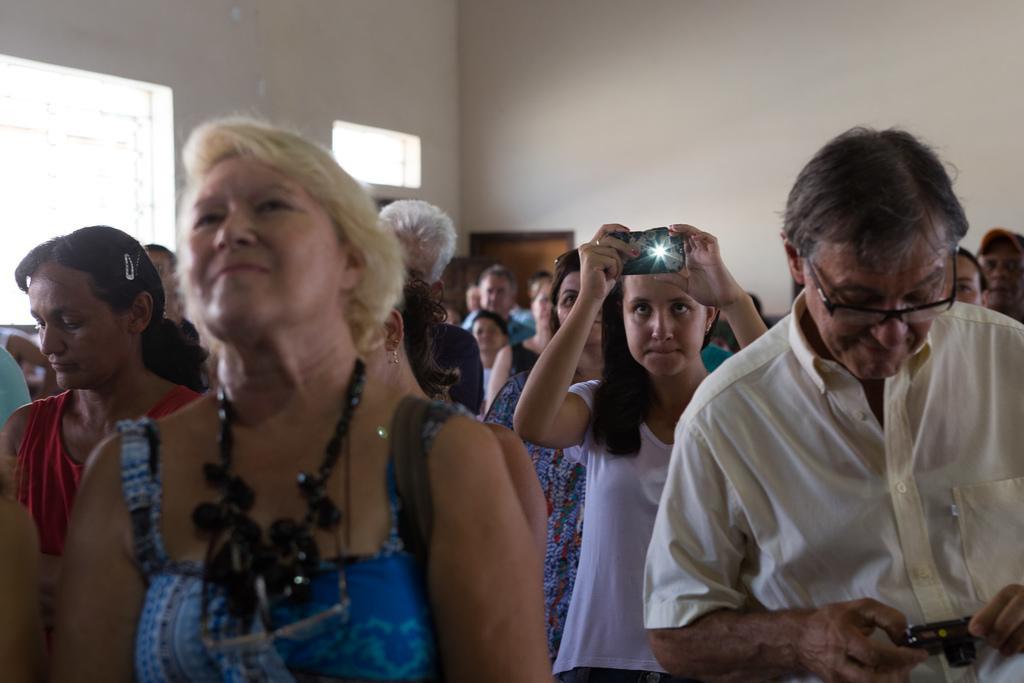In one or two sentences, can you explain what this image depicts? In this image I can see number of persons and I can see few of them are holding cameras in their hands. In the background I can see the wall, the window and the brown colored door. 